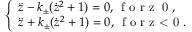Convert formula to latex. <formula><loc_0><loc_0><loc_500><loc_500>\left \{ \begin{array} { l l } { \ddot { z } - k _ { \pm } ( \dot { z } ^ { 2 } + 1 ) = 0 , \, f o r z \geq 0 , } \\ { \ddot { z } + k _ { \pm } ( \dot { z } ^ { 2 } + 1 ) = 0 , \, f o r z < 0 . } \end{array}</formula> 